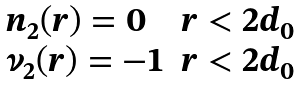<formula> <loc_0><loc_0><loc_500><loc_500>\begin{array} { l l } n _ { 2 } ( r ) = 0 & r < 2 d _ { 0 } \\ \nu _ { 2 } ( r ) = - 1 & r < 2 d _ { 0 } \end{array}</formula> 